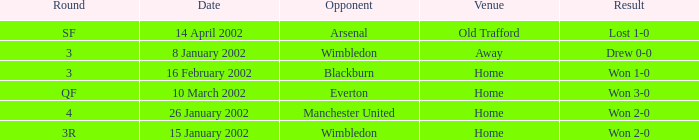What is the Date with a Round with sf? 14 April 2002. 